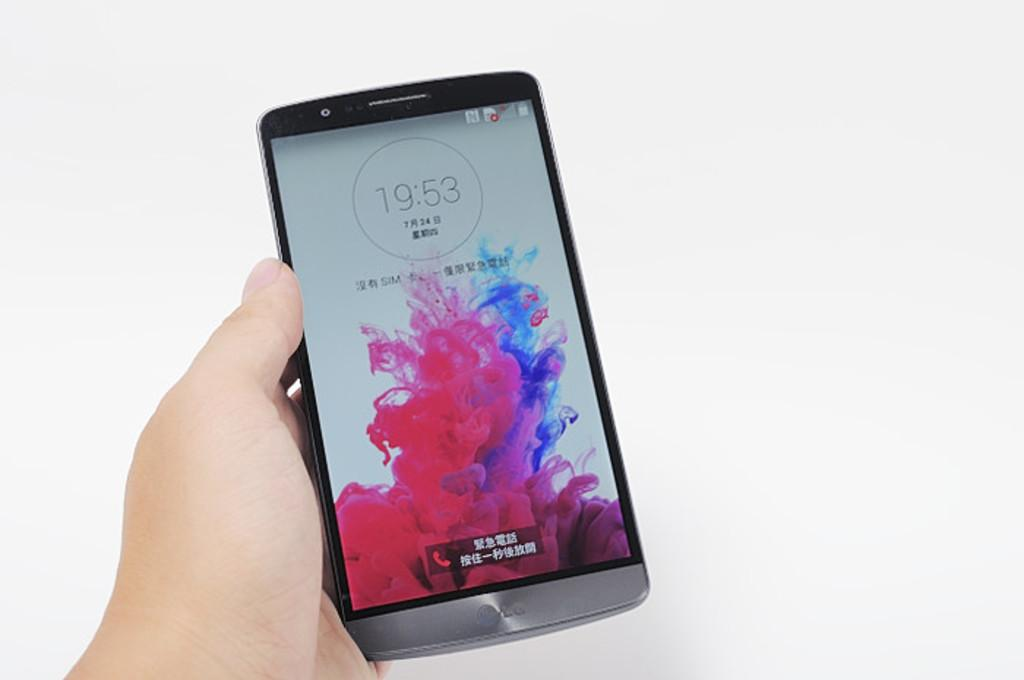<image>
Offer a succinct explanation of the picture presented. a hand holding a phone that reads 19:53 